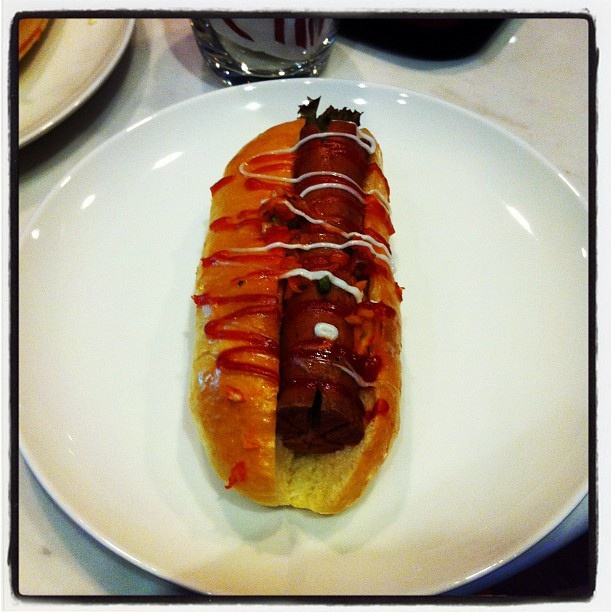Describe the objects in this image and their specific colors. I can see dining table in beige, white, darkgray, and black tones, hot dog in white, maroon, brown, and black tones, and cup in white, black, and gray tones in this image. 